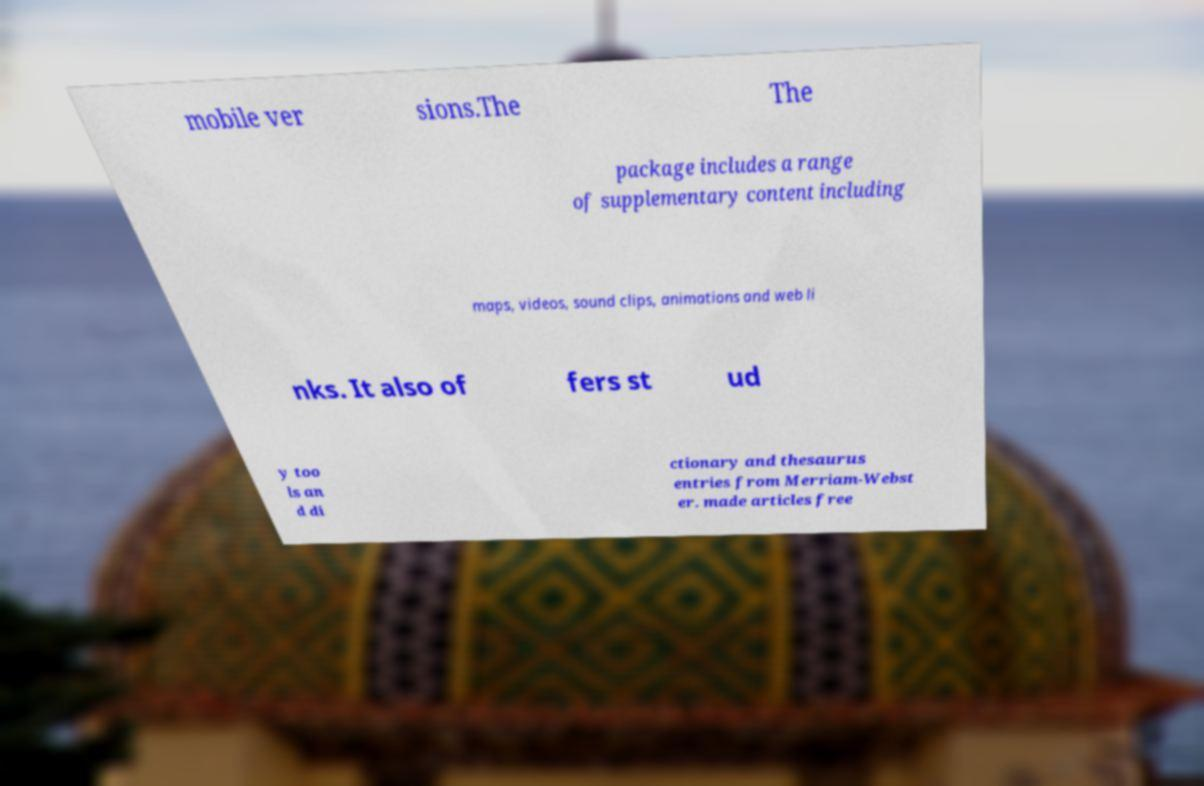Could you extract and type out the text from this image? mobile ver sions.The The package includes a range of supplementary content including maps, videos, sound clips, animations and web li nks. It also of fers st ud y too ls an d di ctionary and thesaurus entries from Merriam-Webst er. made articles free 